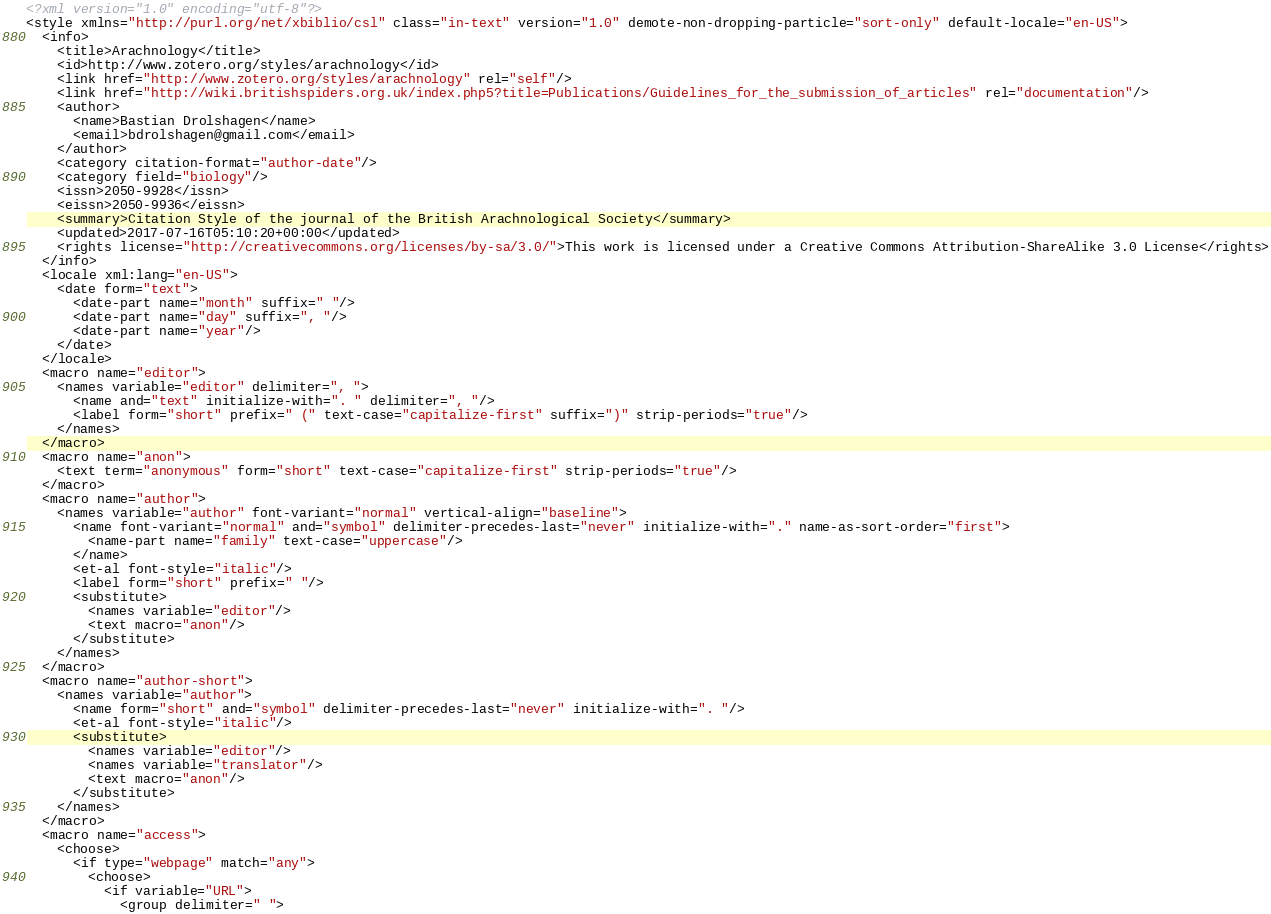Convert code to text. <code><loc_0><loc_0><loc_500><loc_500><_XML_><?xml version="1.0" encoding="utf-8"?>
<style xmlns="http://purl.org/net/xbiblio/csl" class="in-text" version="1.0" demote-non-dropping-particle="sort-only" default-locale="en-US">
  <info>
    <title>Arachnology</title>
    <id>http://www.zotero.org/styles/arachnology</id>
    <link href="http://www.zotero.org/styles/arachnology" rel="self"/>
    <link href="http://wiki.britishspiders.org.uk/index.php5?title=Publications/Guidelines_for_the_submission_of_articles" rel="documentation"/>
    <author>
      <name>Bastian Drolshagen</name>
      <email>bdrolshagen@gmail.com</email>
    </author>
    <category citation-format="author-date"/>
    <category field="biology"/>
    <issn>2050-9928</issn>
    <eissn>2050-9936</eissn>
    <summary>Citation Style of the journal of the British Arachnological Society</summary>
    <updated>2017-07-16T05:10:20+00:00</updated>
    <rights license="http://creativecommons.org/licenses/by-sa/3.0/">This work is licensed under a Creative Commons Attribution-ShareAlike 3.0 License</rights>
  </info>
  <locale xml:lang="en-US">
    <date form="text">
      <date-part name="month" suffix=" "/>
      <date-part name="day" suffix=", "/>
      <date-part name="year"/>
    </date>
  </locale>
  <macro name="editor">
    <names variable="editor" delimiter=", ">
      <name and="text" initialize-with=". " delimiter=", "/>
      <label form="short" prefix=" (" text-case="capitalize-first" suffix=")" strip-periods="true"/>
    </names>
  </macro>
  <macro name="anon">
    <text term="anonymous" form="short" text-case="capitalize-first" strip-periods="true"/>
  </macro>
  <macro name="author">
    <names variable="author" font-variant="normal" vertical-align="baseline">
      <name font-variant="normal" and="symbol" delimiter-precedes-last="never" initialize-with="." name-as-sort-order="first">
        <name-part name="family" text-case="uppercase"/>
      </name>
      <et-al font-style="italic"/>
      <label form="short" prefix=" "/>
      <substitute>
        <names variable="editor"/>
        <text macro="anon"/>
      </substitute>
    </names>
  </macro>
  <macro name="author-short">
    <names variable="author">
      <name form="short" and="symbol" delimiter-precedes-last="never" initialize-with=". "/>
      <et-al font-style="italic"/>
      <substitute>
        <names variable="editor"/>
        <names variable="translator"/>
        <text macro="anon"/>
      </substitute>
    </names>
  </macro>
  <macro name="access">
    <choose>
      <if type="webpage" match="any">
        <choose>
          <if variable="URL">
            <group delimiter=" "></code> 